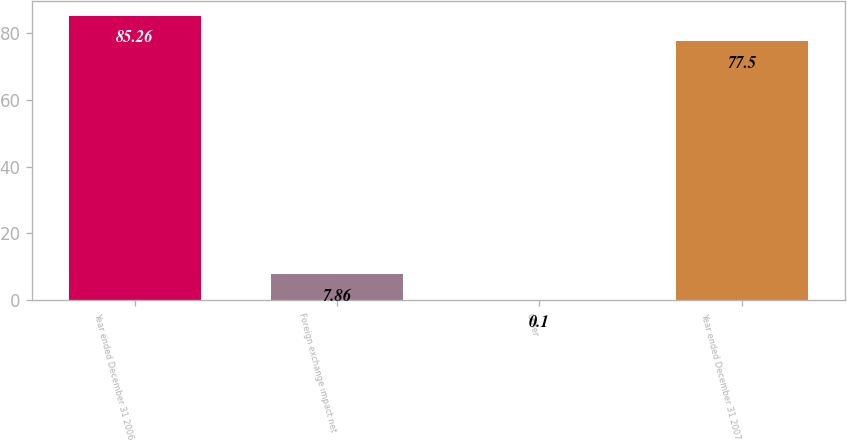Convert chart. <chart><loc_0><loc_0><loc_500><loc_500><bar_chart><fcel>Year ended December 31 2006<fcel>Foreign exchange impact net<fcel>Other<fcel>Year ended December 31 2007<nl><fcel>85.26<fcel>7.86<fcel>0.1<fcel>77.5<nl></chart> 